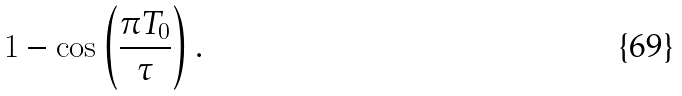<formula> <loc_0><loc_0><loc_500><loc_500>1 - \cos \left ( \frac { \pi T _ { 0 } } { \tau } \right ) .</formula> 